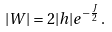<formula> <loc_0><loc_0><loc_500><loc_500>| W | = 2 | h | e ^ { - \frac { J } { 2 } } \, .</formula> 